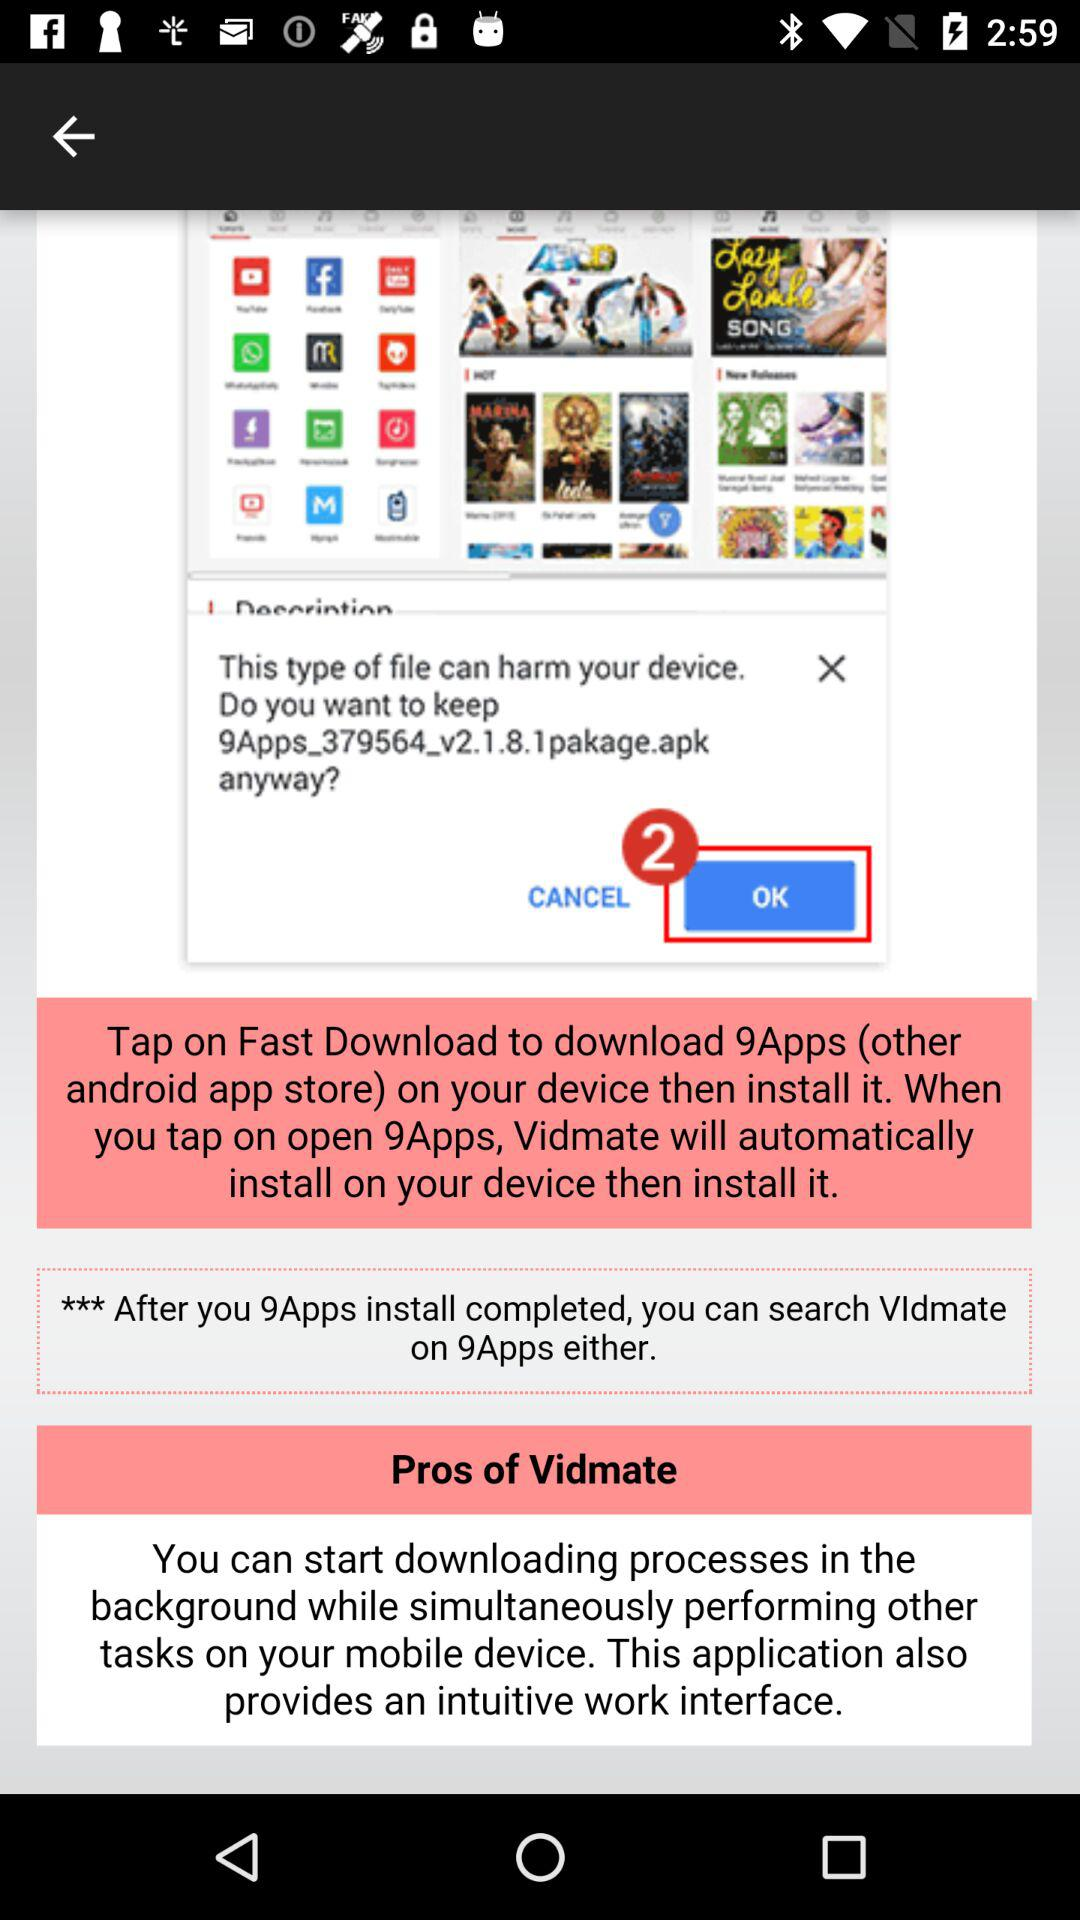What is the date?
When the provided information is insufficient, respond with <no answer>. <no answer> 